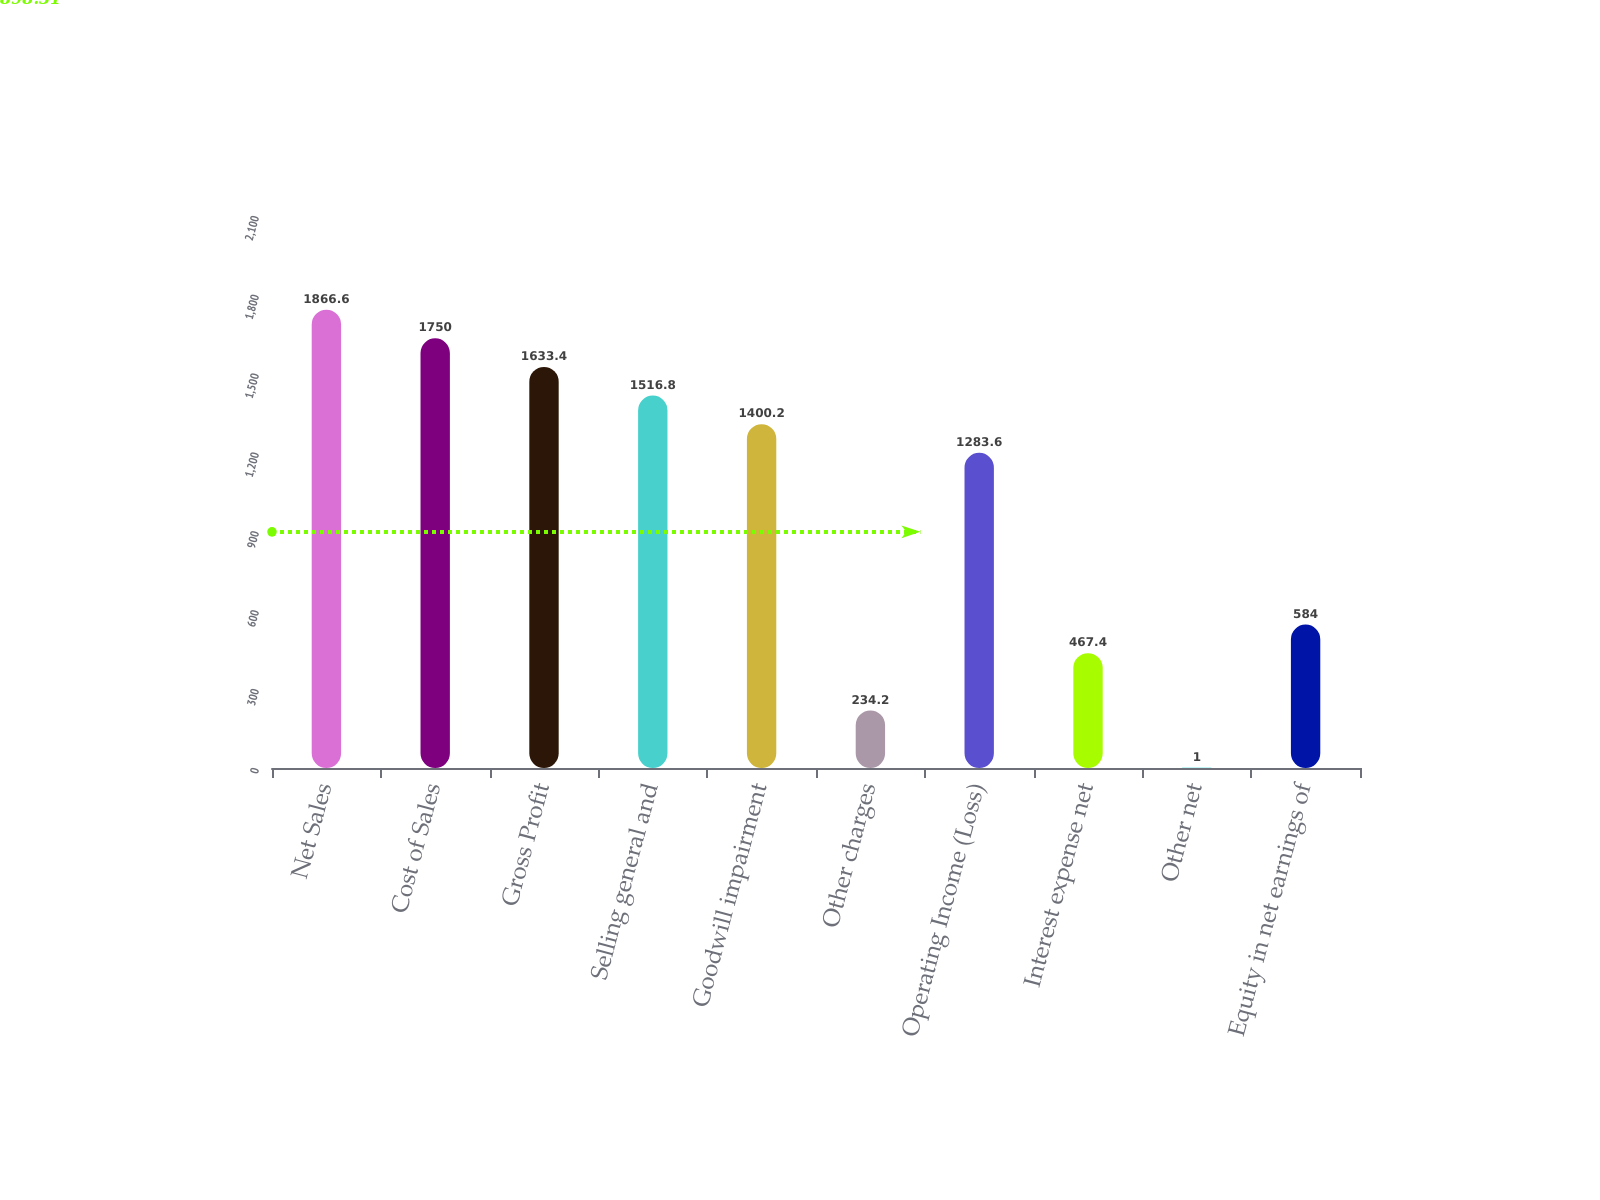Convert chart. <chart><loc_0><loc_0><loc_500><loc_500><bar_chart><fcel>Net Sales<fcel>Cost of Sales<fcel>Gross Profit<fcel>Selling general and<fcel>Goodwill impairment<fcel>Other charges<fcel>Operating Income (Loss)<fcel>Interest expense net<fcel>Other net<fcel>Equity in net earnings of<nl><fcel>1866.6<fcel>1750<fcel>1633.4<fcel>1516.8<fcel>1400.2<fcel>234.2<fcel>1283.6<fcel>467.4<fcel>1<fcel>584<nl></chart> 